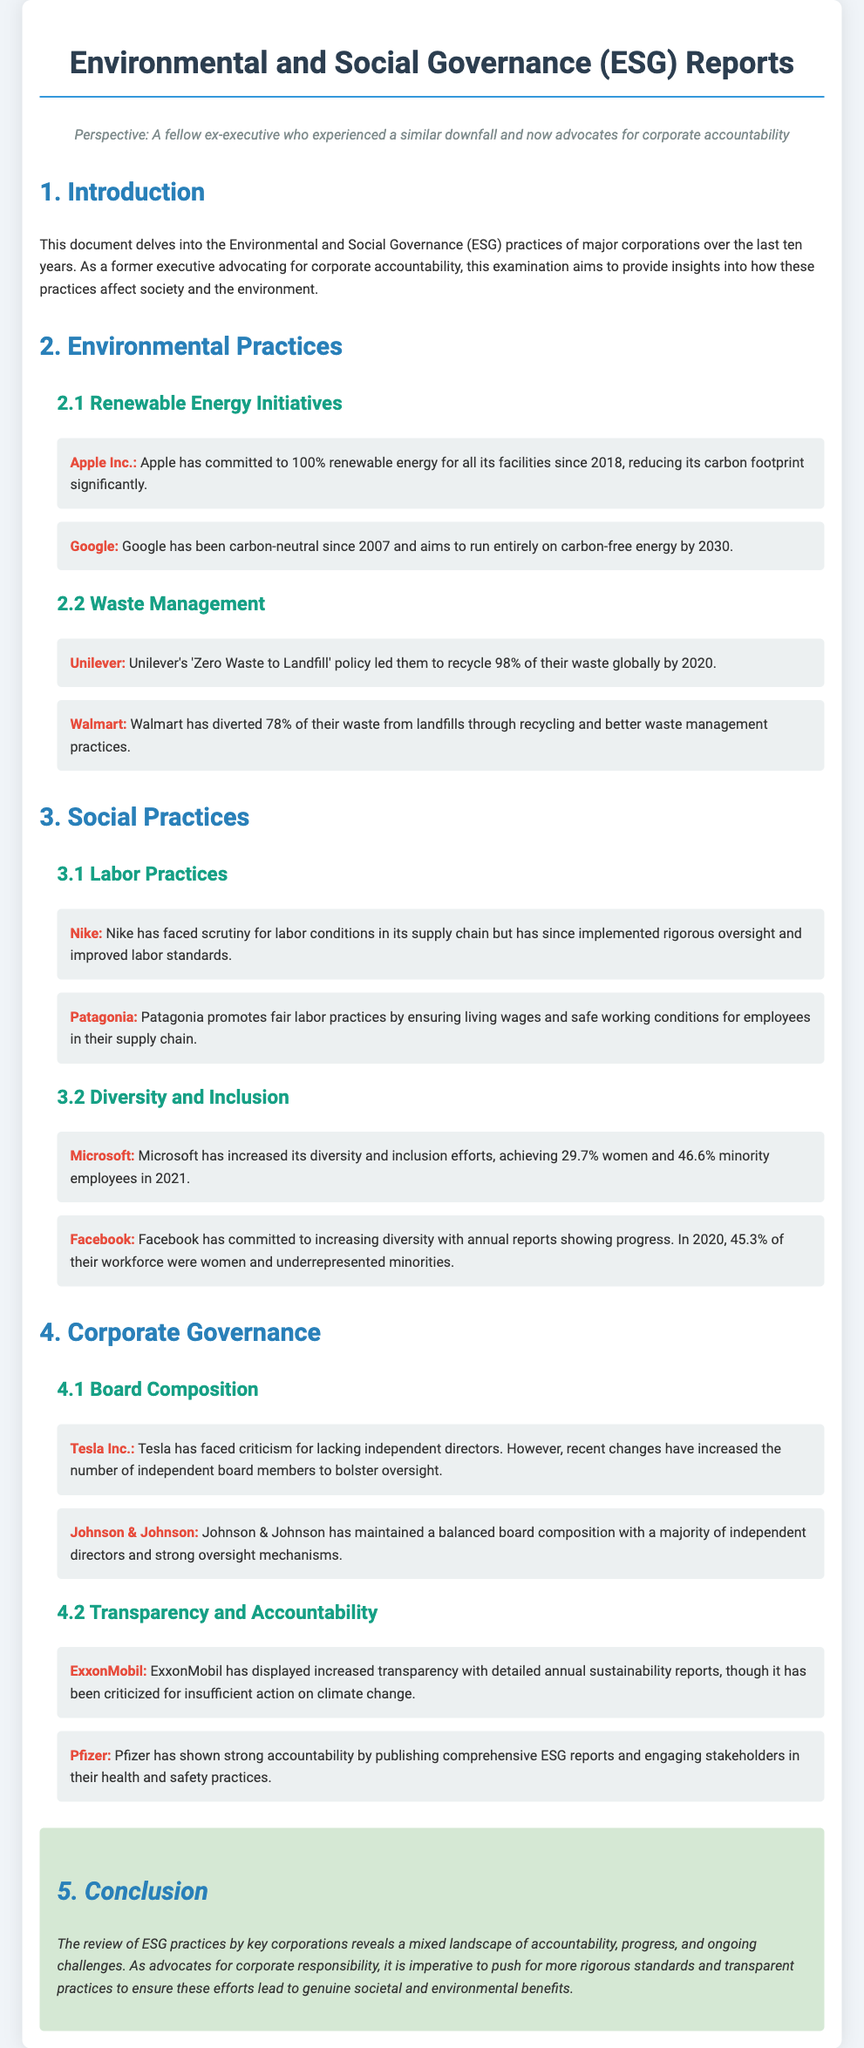What is the title of the document? The title is stated in the header section of the document.
Answer: Environmental and Social Governance (ESG) Reports: A Detailed Examination of Corporate Practices and Their Impact on Society from Various Firms in the Last Decade Which company committed to 100% renewable energy by 2018? This detail is mentioned in the Environmental Practices section under Renewable Energy Initiatives.
Answer: Apple Inc What percentage of Unilever's waste was recycled by 2020? This information can be found in the Waste Management subsection under Environmental Practices.
Answer: 98% What was Microsoft's percentage of minority employees in 2021? This statistic is provided in the Diversity and Inclusion subsection under Social Practices.
Answer: 46.6% Which company has increased its board's number of independent directors? This information is mentioned in the Corporate Governance section under Board Composition.
Answer: Tesla Inc What does Pfizer publish to show strong accountability? This detail is specified in the Transparency and Accountability subsection under Corporate Governance.
Answer: Comprehensive ESG reports Which company has been carbon-neutral since 2007? This fact is mentioned in the Renewable Energy Initiatives subsection under Environmental Practices.
Answer: Google What is the conclusion regarding the landscape of corporate accountability? The conclusion summarizes the overall findings presented in the final section of the document.
Answer: Mixed landscape of accountability, progress, and ongoing challenges 